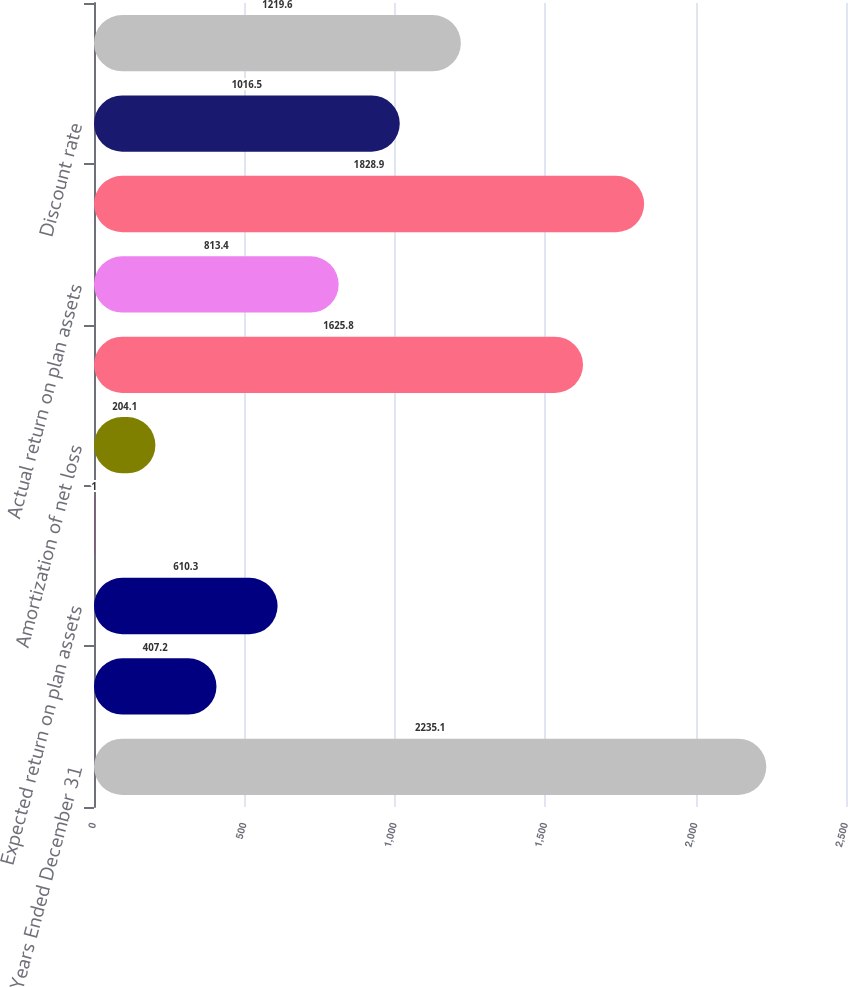<chart> <loc_0><loc_0><loc_500><loc_500><bar_chart><fcel>Years Ended December 31<fcel>Interest cost<fcel>Expected return on plan assets<fcel>Amortization of prior service<fcel>Amortization of net loss<fcel>Net periodic postretirement<fcel>Actual return on plan assets<fcel>Actual rate of return on plan<fcel>Discount rate<fcel>Expected long-term return on<nl><fcel>2235.1<fcel>407.2<fcel>610.3<fcel>1<fcel>204.1<fcel>1625.8<fcel>813.4<fcel>1828.9<fcel>1016.5<fcel>1219.6<nl></chart> 